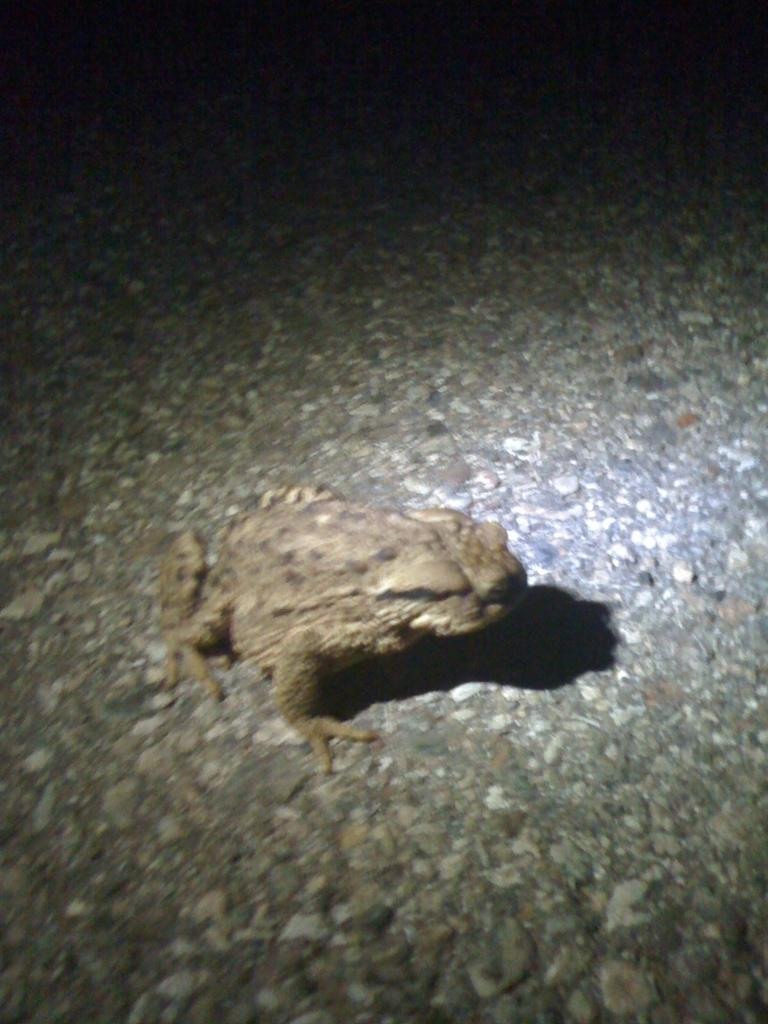What type of animal is in the image? There is a frog in the image. Can you describe the quality of the image? The image is a little bit blurry. What type of books does the lawyer bring to the meal in the image? There are no books, lawyers, or meals present in the image; it only features a frog. 